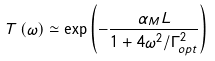Convert formula to latex. <formula><loc_0><loc_0><loc_500><loc_500>T \left ( \omega \right ) \simeq \exp \left ( - \frac { \alpha _ { M } L } { 1 + 4 \omega ^ { 2 } / \Gamma _ { o p t } ^ { 2 } } \right )</formula> 